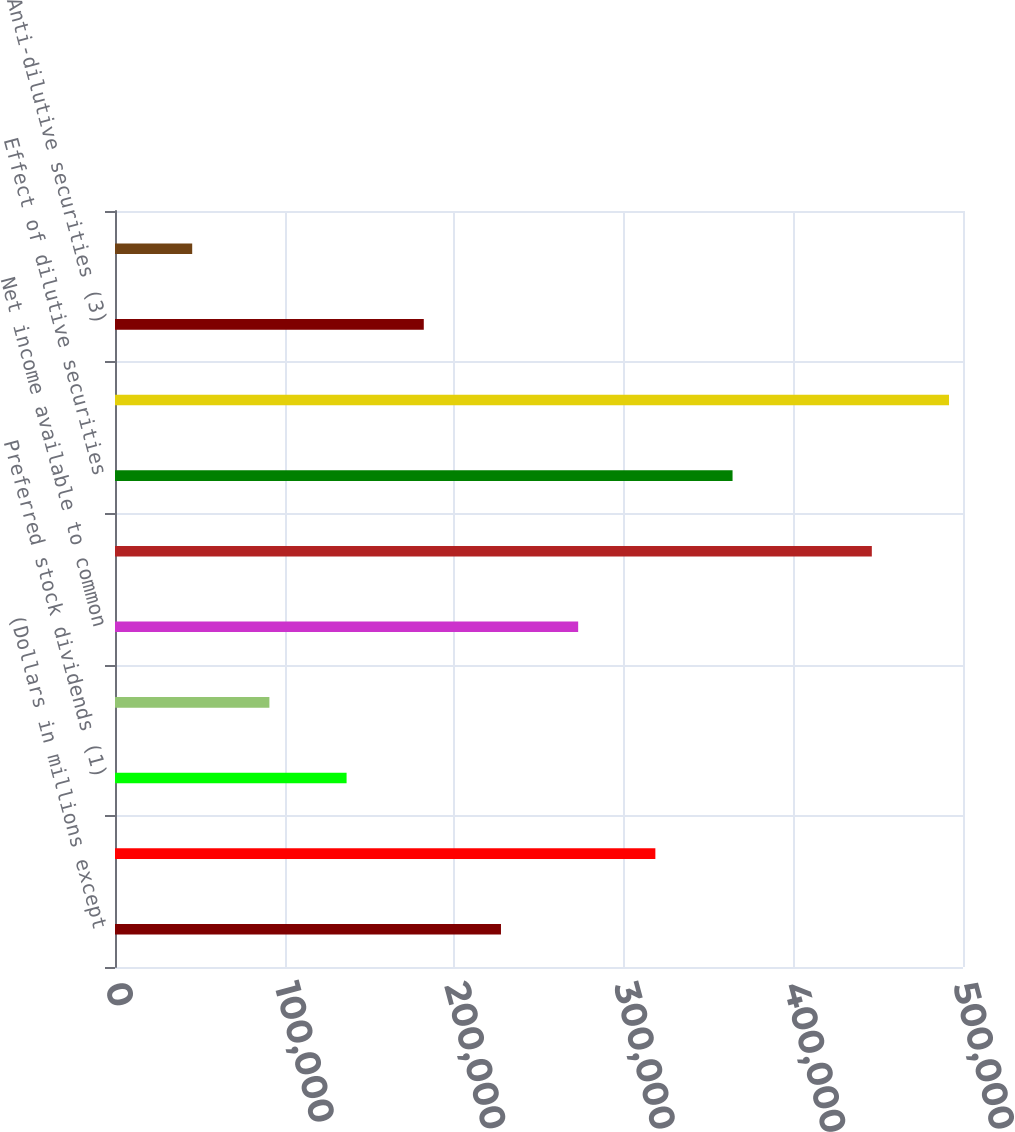Convert chart to OTSL. <chart><loc_0><loc_0><loc_500><loc_500><bar_chart><fcel>(Dollars in millions except<fcel>Net income<fcel>Preferred stock dividends (1)<fcel>Dividends and undistributed<fcel>Net income available to common<fcel>Basic average common shares<fcel>Effect of dilutive securities<fcel>Diluted average common shares<fcel>Anti-dilutive securities (3)<fcel>Basic<nl><fcel>227580<fcel>318610<fcel>136550<fcel>91034.7<fcel>273095<fcel>446245<fcel>364125<fcel>491760<fcel>182065<fcel>45519.7<nl></chart> 